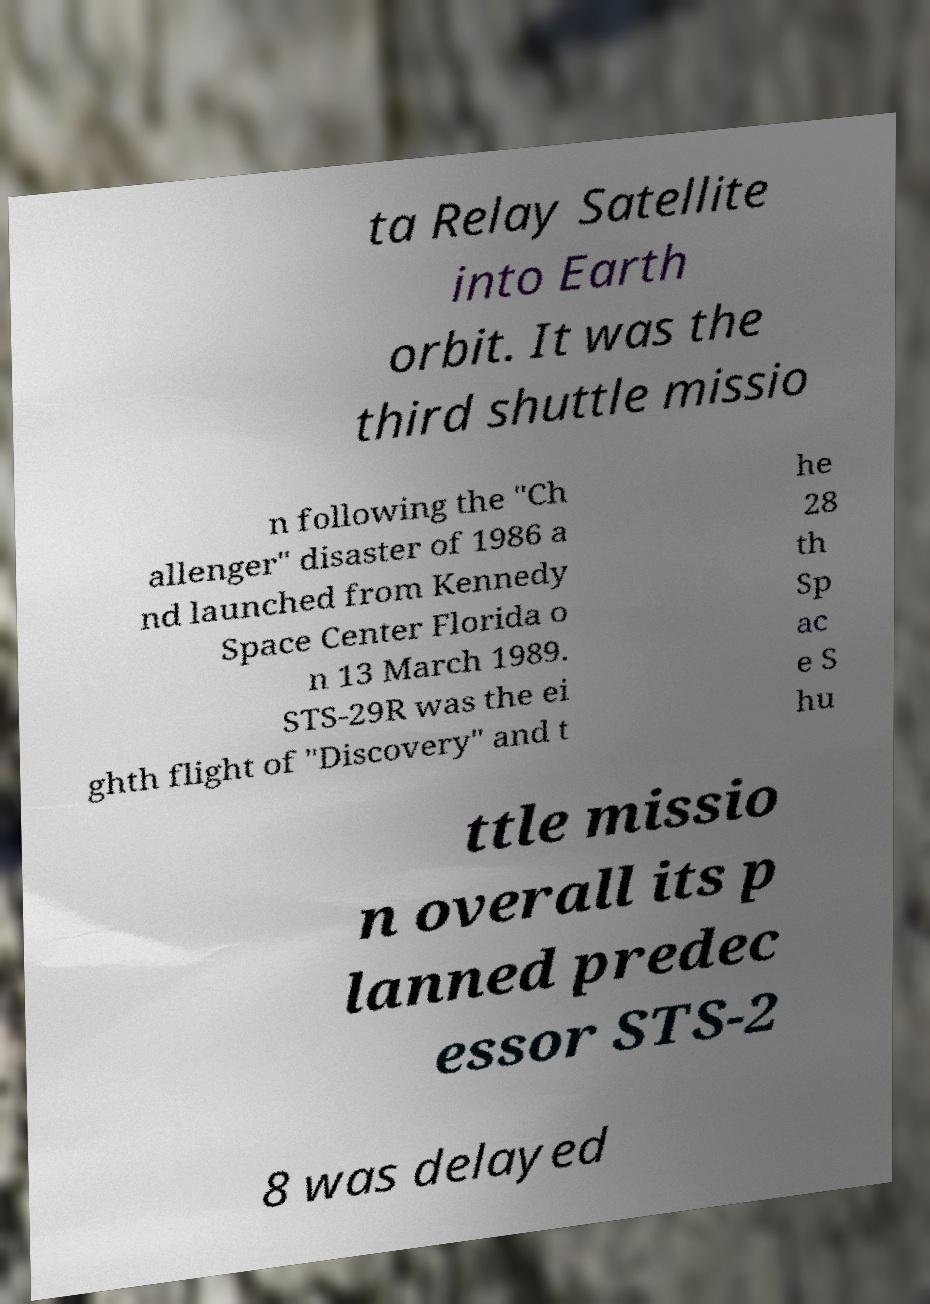What messages or text are displayed in this image? I need them in a readable, typed format. ta Relay Satellite into Earth orbit. It was the third shuttle missio n following the "Ch allenger" disaster of 1986 a nd launched from Kennedy Space Center Florida o n 13 March 1989. STS-29R was the ei ghth flight of "Discovery" and t he 28 th Sp ac e S hu ttle missio n overall its p lanned predec essor STS-2 8 was delayed 